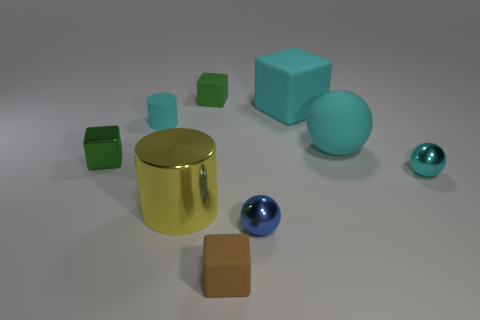Is there anything else that is the same material as the small cyan cylinder?
Keep it short and to the point. Yes. What number of cyan balls are there?
Give a very brief answer. 2. Is the color of the matte cylinder the same as the big rubber sphere?
Your answer should be very brief. Yes. The object that is to the left of the yellow thing and in front of the rubber cylinder is what color?
Provide a short and direct response. Green. There is a cyan matte block; are there any blocks behind it?
Make the answer very short. Yes. There is a shiny cylinder that is to the left of the tiny blue thing; how many large yellow shiny objects are in front of it?
Offer a very short reply. 0. What size is the green object that is the same material as the tiny brown cube?
Keep it short and to the point. Small. The yellow cylinder is what size?
Give a very brief answer. Large. Do the yellow cylinder and the cyan cube have the same material?
Offer a terse response. No. What number of cubes are either big yellow things or tiny green objects?
Make the answer very short. 2. 